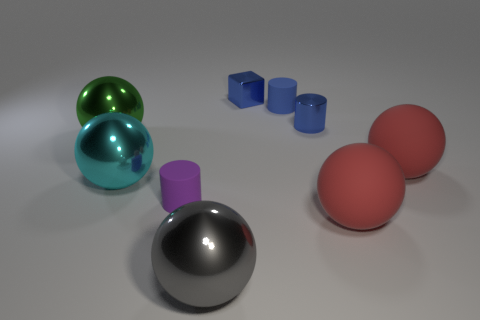Subtract all big matte spheres. How many spheres are left? 3 Add 1 big gray shiny spheres. How many objects exist? 10 Subtract all purple cylinders. How many red balls are left? 2 Subtract all blue cylinders. How many cylinders are left? 1 Subtract all rubber objects. Subtract all gray shiny cubes. How many objects are left? 5 Add 1 large green objects. How many large green objects are left? 2 Add 6 big rubber spheres. How many big rubber spheres exist? 8 Subtract 1 green balls. How many objects are left? 8 Subtract all cylinders. How many objects are left? 6 Subtract all brown balls. Subtract all yellow blocks. How many balls are left? 5 